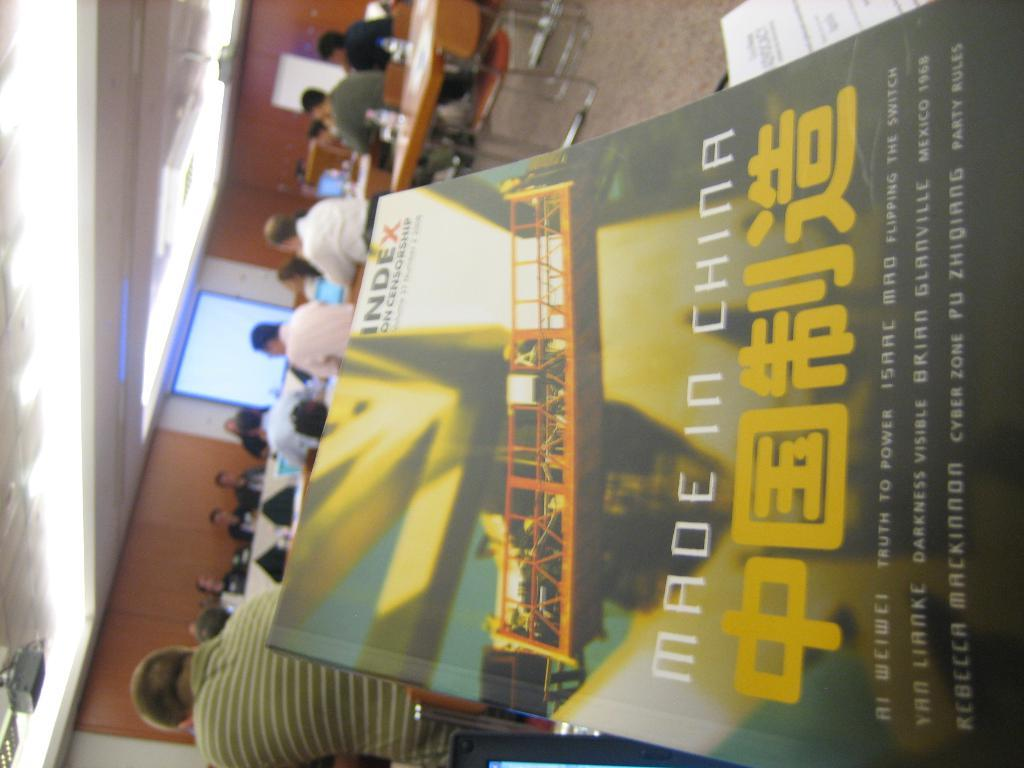<image>
Share a concise interpretation of the image provided. A book titled Made in China that has Chinese characters on the cover. 